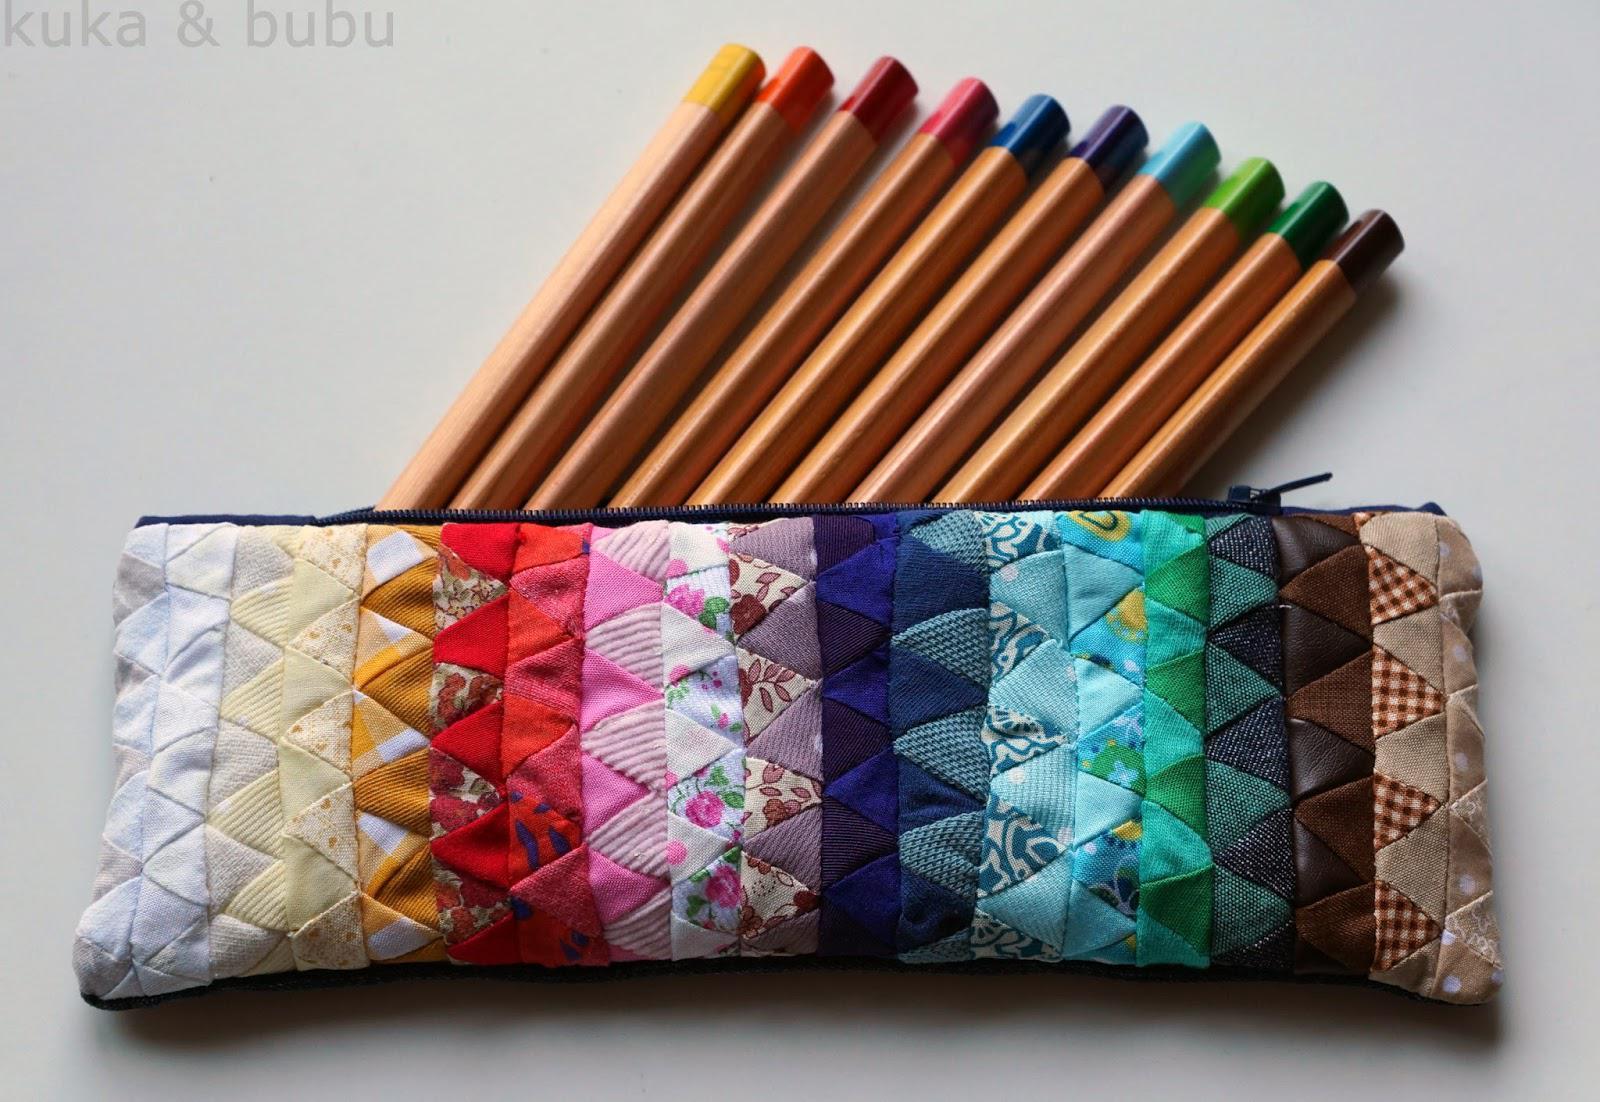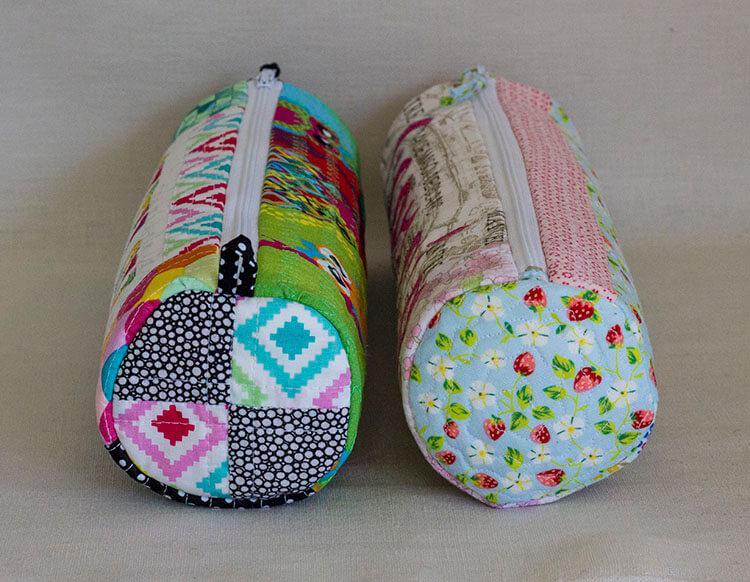The first image is the image on the left, the second image is the image on the right. Assess this claim about the two images: "An image shows a set of colored pencils sticking out of a soft pencil case.". Correct or not? Answer yes or no. Yes. The first image is the image on the left, the second image is the image on the right. For the images displayed, is the sentence "Color pencils are poking out of a pencil case in the image on the left." factually correct? Answer yes or no. Yes. 